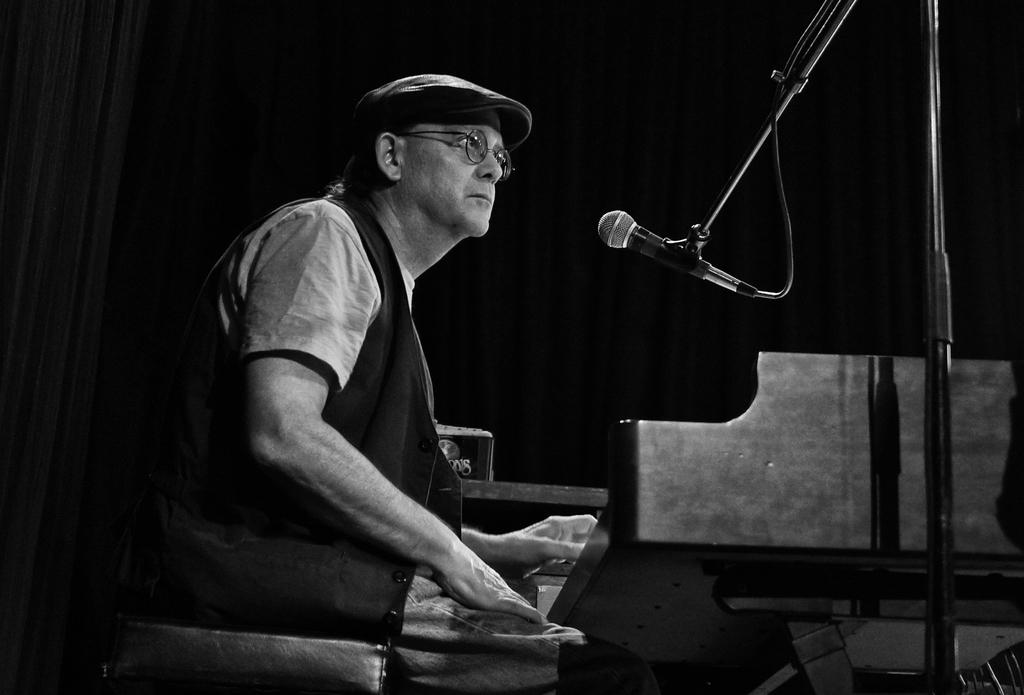What is the color scheme of the image? The image is black and white. What is the person in the image doing? The person is sitting in the image. What accessories is the person wearing? The person is wearing glasses (specs) and a cap. What equipment is in front of the person? There is a microphone (mic) with a mic stand in front of the person. What can be seen in the background of the image? There is a curtain in the background of the image. How many frogs are sitting on the person's cap in the image? There are no frogs present in the image, and therefore none are sitting on the person's cap. What advice does the person's grandfather give in the image? There is no mention of a grandfather or any advice in the image. 